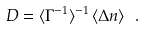Convert formula to latex. <formula><loc_0><loc_0><loc_500><loc_500>D = \langle \Gamma ^ { - 1 } \rangle ^ { - 1 } \, \langle \Delta n \rangle \ .</formula> 